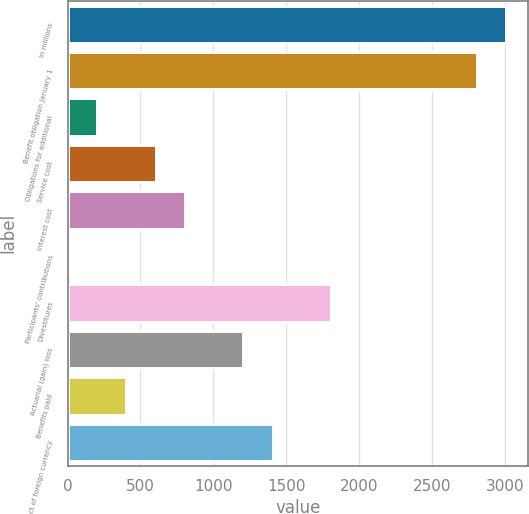Convert chart to OTSL. <chart><loc_0><loc_0><loc_500><loc_500><bar_chart><fcel>In millions<fcel>Benefit obligation January 1<fcel>Obligations for additional<fcel>Service cost<fcel>Interest cost<fcel>Participants' contributions<fcel>Divestitures<fcel>Actuarial (gain) loss<fcel>Benefits paid<fcel>Effect of foreign currency<nl><fcel>3007.5<fcel>2807.2<fcel>203.3<fcel>603.9<fcel>804.2<fcel>3<fcel>1805.7<fcel>1204.8<fcel>403.6<fcel>1405.1<nl></chart> 